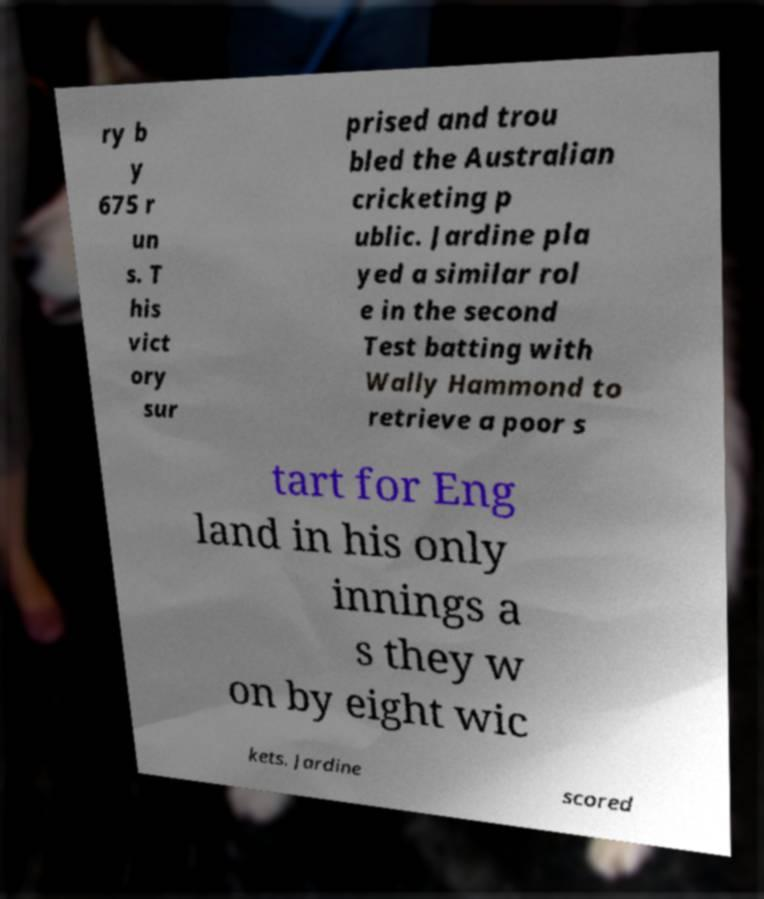Can you accurately transcribe the text from the provided image for me? ry b y 675 r un s. T his vict ory sur prised and trou bled the Australian cricketing p ublic. Jardine pla yed a similar rol e in the second Test batting with Wally Hammond to retrieve a poor s tart for Eng land in his only innings a s they w on by eight wic kets. Jardine scored 